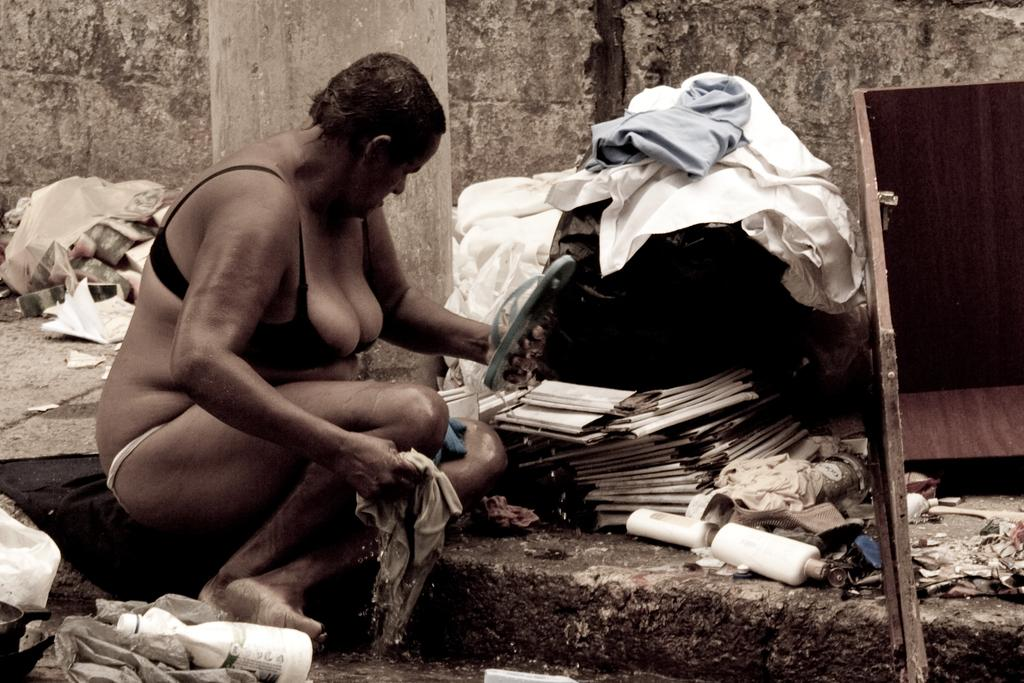What is the woman doing in the image? The woman is sitting in the image. Where is the woman located in the image? The woman is on the left side of the image. What can be seen at the bottom left corner of the image? There is a bottle at the bottom left corner of the image. What type of furniture is on the right side of the image? There is wooden furniture on the right side of the image. What type of punishment is the woman receiving in the image? There is no indication of punishment in the image; the woman is simply sitting. 